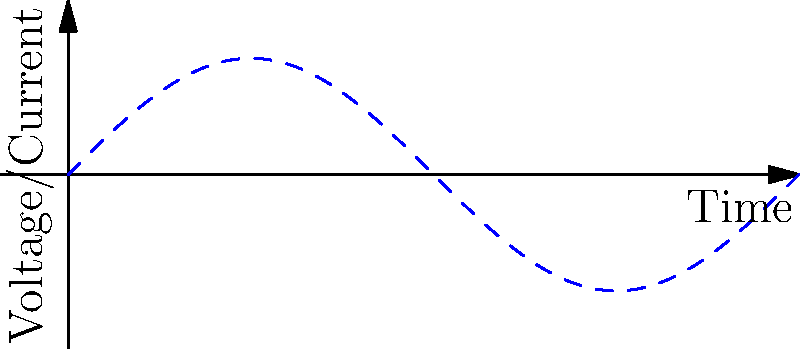In a full-wave bridge rectifier circuit, what is the relationship between the frequency of the rectified output voltage and the frequency of the input AC voltage? How does this compare to the output of a half-wave rectifier? To answer this question, let's analyze the full-wave bridge rectifier circuit step-by-step:

1. Input AC voltage: The input is a sinusoidal AC voltage with frequency $f$.

2. Full-wave rectification process:
   a. During the positive half-cycle, two diodes conduct, allowing current to flow.
   b. During the negative half-cycle, the other two diodes conduct, reversing the current direction in the load.
   c. This results in both half-cycles of the AC input being utilized.

3. Rectified output:
   a. The output waveform consists of a series of positive half-sine waves.
   b. Each complete input cycle (positive and negative) produces two output pulses.

4. Frequency relationship:
   a. For every input cycle, there are two output pulses.
   b. Therefore, the frequency of the rectified output is twice the input frequency.
   c. Mathematically, $f_{output} = 2f_{input}$

5. Comparison with half-wave rectifier:
   a. In a half-wave rectifier, only one half-cycle (positive or negative) is utilized.
   b. The output frequency of a half-wave rectifier is the same as the input frequency.

6. Chess analogy (for our Slovenian chess enthusiast):
   Imagine the input AC cycles as chess moves, and the rectified output as points scored. In a full-wave rectifier, you score on both white and black moves (like Enver Bukić's aggressive style), doubling your frequency of scoring compared to a half-wave rectifier where you only score on one color's moves.
Answer: The frequency of the rectified output is twice the input frequency ($f_{output} = 2f_{input}$), unlike a half-wave rectifier where they are equal. 